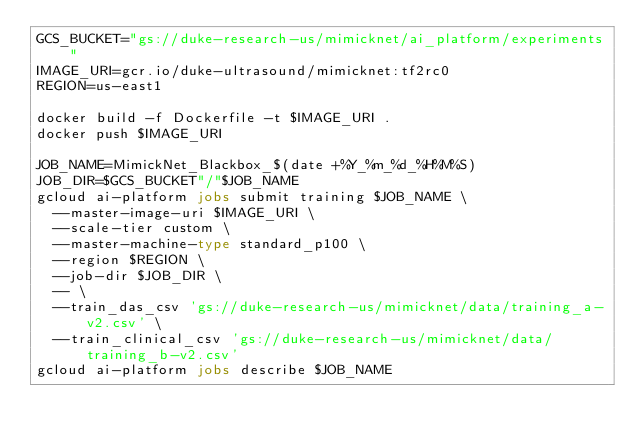Convert code to text. <code><loc_0><loc_0><loc_500><loc_500><_Bash_>GCS_BUCKET="gs://duke-research-us/mimicknet/ai_platform/experiments"
IMAGE_URI=gcr.io/duke-ultrasound/mimicknet:tf2rc0
REGION=us-east1

docker build -f Dockerfile -t $IMAGE_URI .
docker push $IMAGE_URI

JOB_NAME=MimickNet_Blackbox_$(date +%Y_%m_%d_%H%M%S)
JOB_DIR=$GCS_BUCKET"/"$JOB_NAME
gcloud ai-platform jobs submit training $JOB_NAME \
  --master-image-uri $IMAGE_URI \
  --scale-tier custom \
  --master-machine-type standard_p100 \
  --region $REGION \
  --job-dir $JOB_DIR \
  -- \
  --train_das_csv 'gs://duke-research-us/mimicknet/data/training_a-v2.csv' \
  --train_clinical_csv 'gs://duke-research-us/mimicknet/data/training_b-v2.csv'
gcloud ai-platform jobs describe $JOB_NAME
</code> 